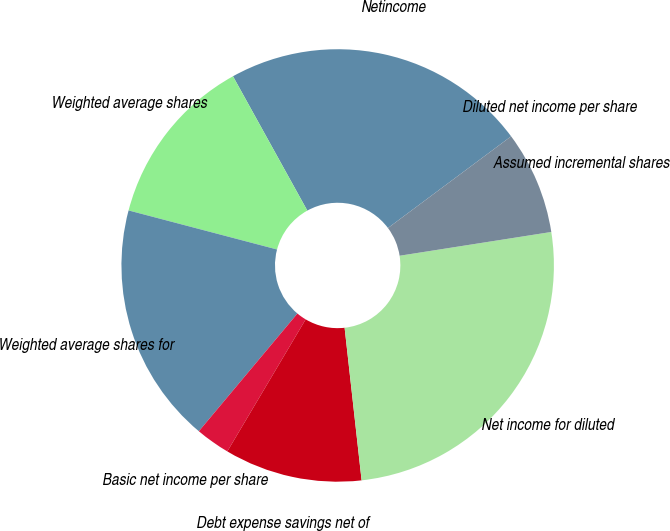<chart> <loc_0><loc_0><loc_500><loc_500><pie_chart><fcel>Netincome<fcel>Weighted average shares<fcel>Weighted average shares for<fcel>Basic net income per share<fcel>Debt expense savings net of<fcel>Net income for diluted<fcel>Assumed incremental shares<fcel>Diluted net income per share<nl><fcel>22.86%<fcel>12.86%<fcel>18.0%<fcel>2.57%<fcel>10.29%<fcel>25.71%<fcel>7.71%<fcel>0.0%<nl></chart> 